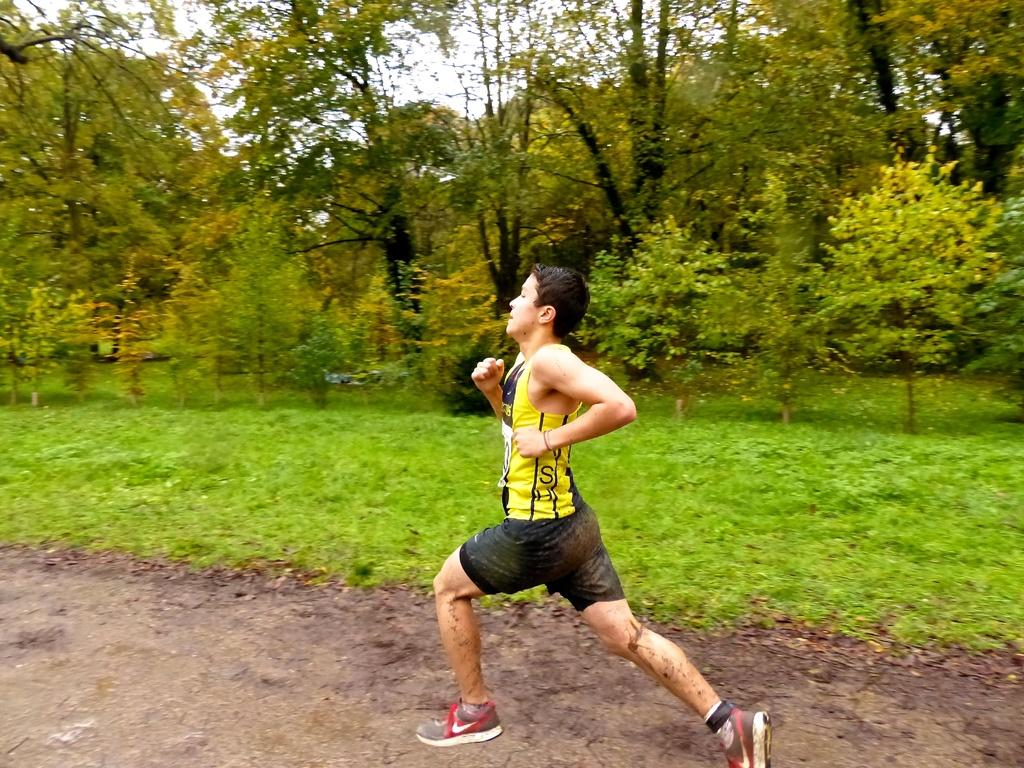Who or what is the main subject in the image? There is a person in the image. What is the person wearing? The person is wearing a dress. Where is the person located in the image? The person is standing on the ground. What can be seen in the background of the image? There is a group of trees and the sky visible in the background of the image. What type of fan is being used by the person in the image? There is no fan present in the image; the person is simply standing on the ground. 